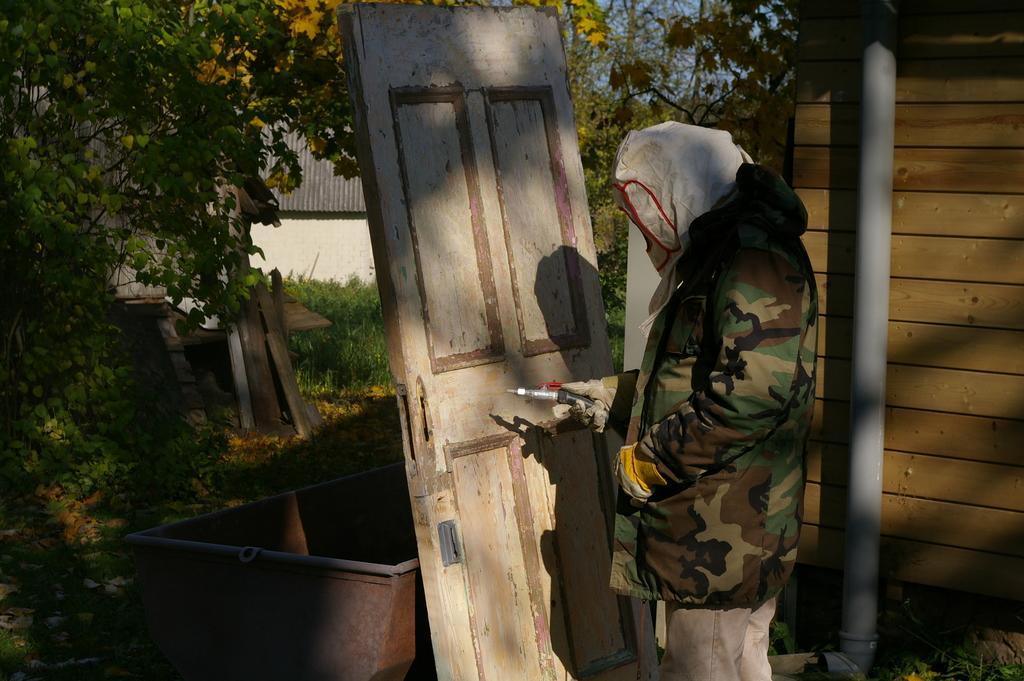Describe this image in one or two sentences. In this image I can see the person standing and the person is holding some object. Background I can see a pipe attached to the wooden wall and I can see trees in green color, flowers in yellow color and the sky is in blue color. 